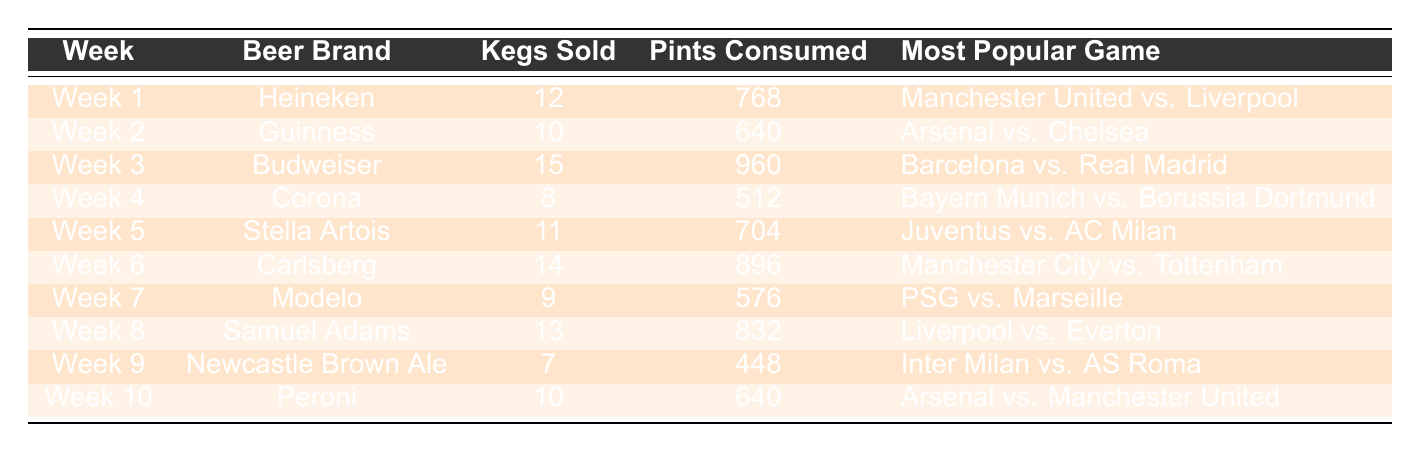What was the most popular game during Week 3? The table shows that the most popular game for Week 3 was "Barcelona vs. Real Madrid." We simply need to look at the entry for Week 3 in the "Most Popular Game" column.
Answer: Barcelona vs. Real Madrid How many kegs of Budweiser were sold in Week 3? According to the table, Week 3 indicates that 15 kegs of Budweiser were sold. This information is found directly in the "Kegs Sold" column for Week 3.
Answer: 15 Which beer brand had the highest pints consumed and how many? By reviewing the table, we see that Budweiser, in Week 3, had the highest pints consumed at 960. We can determine this by comparing the "Pints Consumed" values in all rows.
Answer: Budweiser, 960 What is the total number of kegs sold across all 10 weeks? To find the total kegs sold, we sum the values in the "Kegs Sold" column: 12 + 10 + 15 + 8 + 11 + 14 + 9 + 13 + 7 + 10 = 119. This involves adding all the kegs sold from each week.
Answer: 119 Was there any week where more than 800 pints were consumed? Yes, several weeks had over 800 pints consumed. Specifically, Week 1 (768), Week 3 (960), Week 6 (896), and Week 8 (832) all exceed 800 pints. We check each row in the "Pints Consumed" column against the threshold of 800.
Answer: Yes What was the average number of kegs sold per week? To find the average kegs sold, we sum the kegs sold (119 from the earlier question) and divide by the number of weeks (10): 119 / 10 = 11.9. This involves first calculating the total kegs and then dividing by the count of weeks.
Answer: 11.9 Which beer brand sold the least number of kegs and how many? The least sold beer brand was Newcastle Brown Ale with 7 kegs sold, as determined by finding the minimum value in the "Kegs Sold" column across the weeks.
Answer: Newcastle Brown Ale, 7 How many weeks featured games involving Manchester United? The table shows that there are two weeks (Week 1 and Week 10) that featured Manchester United in the popular games. We check the "Most Popular Game" column for any mention of Manchester United across all entries.
Answer: 2 